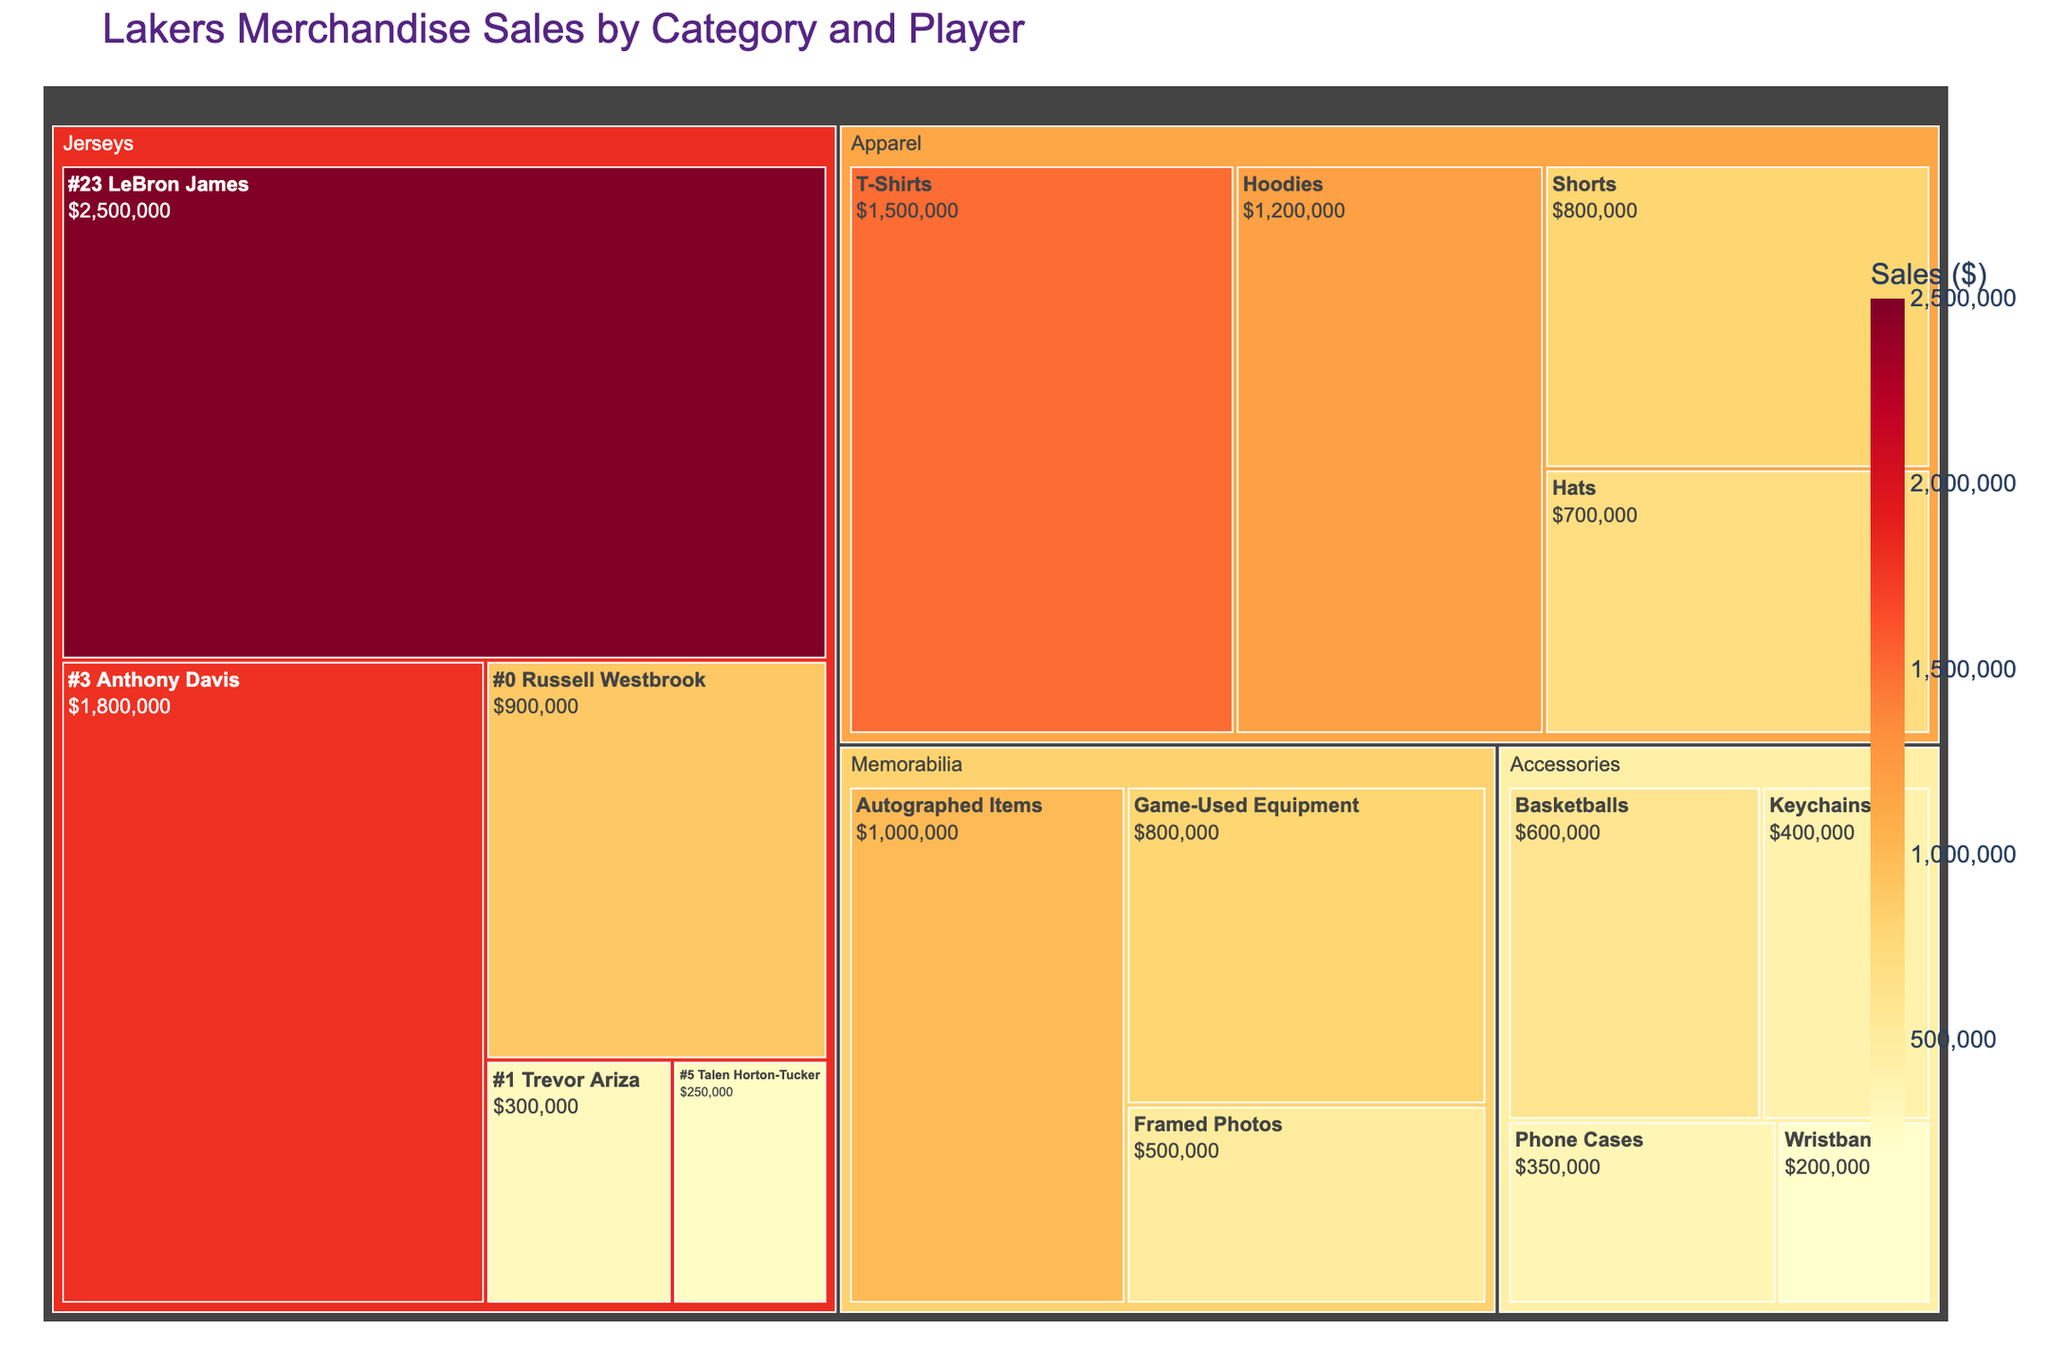Which product category has the highest sales? The treemap shows that Jerseys have the highest sales, indicated by the largest section and the darkest color.
Answer: Jerseys Which player's jersey has the highest sales? By examining the Jerseys subcategory, the section for #23 LeBron James is the largest and darkest, indicating the highest sales.
Answer: #23 LeBron James How do sales of #3 Anthony Davis jerseys compare to #0 Russell Westbrook jerseys? The treemap indicates that #3 Anthony Davis jerseys have a larger section and darker color than #0 Russell Westbrook jerseys, which means the sales are higher for Anthony Davis.
Answer: Higher What is the combined sales of all the Memorabilia items? The sections under Memorabilia are Autographed Items ($1,000,000), Game-Used Equipment ($800,000), and Framed Photos ($500,000). Adding these gives $1,000,000 + $800,000 + $500,000.
Answer: $2,300,000 Are sales of Keychains under Accessories higher or lower than sales of T-Shirts under Apparel? The treemap shows that T-Shirts under Apparel have a much larger section and darker color compared to Keychains under Accessories, indicating higher sales for T-Shirts.
Answer: Lower Which is the least selling item under Jerseys? The treemap shows that the section for #5 Talen Horton-Tucker is the smallest and lightest among jerseys.
Answer: #5 Talen Horton-Tucker What is the average sales of items in the Accessories category? The sales for Accessories are: Basketballs ($600,000), Keychains ($400,000), Phone Cases ($350,000), and Wristbands ($200,000). Adding these, we get $600,000 + $400,000 + $350,000 + $200,000 = $1,550,000. Dividing by 4 gives $1,550,000 / 4.
Answer: $387,500 Which category has the most diverse range of sales values? By observing the treemap, we notice that Apparel has a wider range of sizes and colors among its sections (T-Shirts, Hoodies, Shorts, Hats) compared to other categories.
Answer: Apparel What can you say about the total sales of Jerseys compared to Apparel? The treemap shows that the combined area and color intensity of Jerseys is larger and darker than that of Apparel, indicating higher total sales for Jerseys.
Answer: Higher Which has higher sales: Game-Used Equipment or all Wristbands, Keychains, and Phone Cases combined? Sales for Game-Used Equipment are $800,000. Sales for Wristbands ($200,000), Keychains ($400,000), and Phone Cases ($350,000) add up to $950,000. Since $950,000 > $800,000.
Answer: Wristbands, Keychains, and Phone Cases combined 